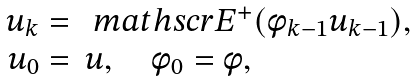Convert formula to latex. <formula><loc_0><loc_0><loc_500><loc_500>\begin{array} { r l } { u } _ { k } = & \ m a t h s c r { E } ^ { + } ( \phi _ { k - 1 } { u } _ { k - 1 } ) , \\ { u } _ { 0 } = & { u } , \quad \phi _ { 0 } = \phi , \end{array}</formula> 